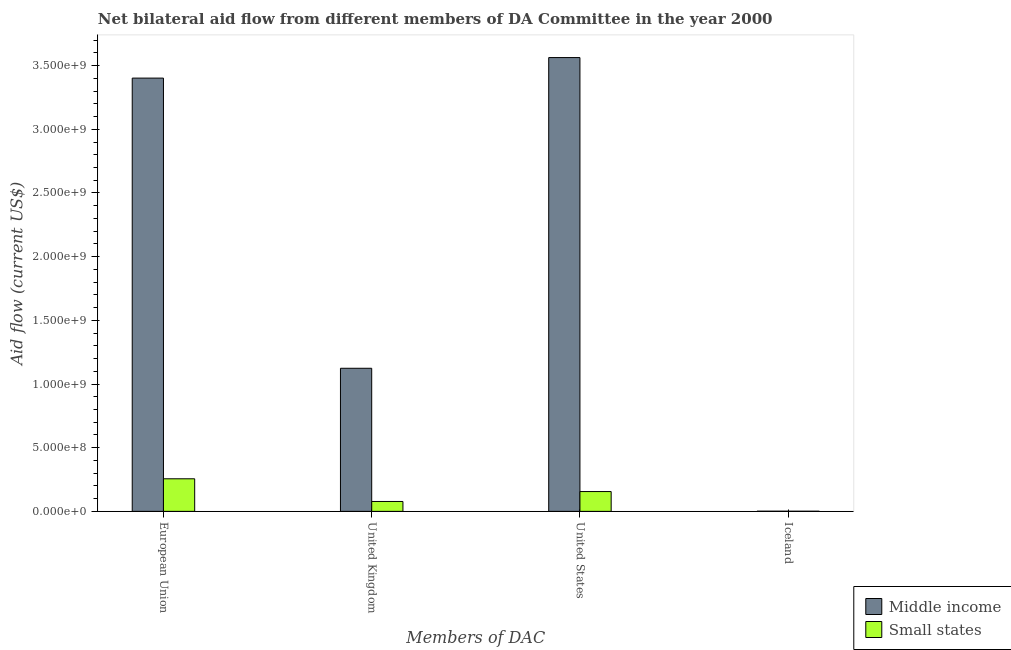Are the number of bars on each tick of the X-axis equal?
Provide a succinct answer. Yes. What is the amount of aid given by uk in Middle income?
Your answer should be very brief. 1.12e+09. Across all countries, what is the maximum amount of aid given by eu?
Offer a very short reply. 3.40e+09. Across all countries, what is the minimum amount of aid given by us?
Your answer should be very brief. 1.56e+08. In which country was the amount of aid given by iceland maximum?
Your answer should be compact. Middle income. In which country was the amount of aid given by eu minimum?
Make the answer very short. Small states. What is the total amount of aid given by us in the graph?
Your answer should be very brief. 3.72e+09. What is the difference between the amount of aid given by eu in Middle income and that in Small states?
Offer a terse response. 3.15e+09. What is the difference between the amount of aid given by uk in Small states and the amount of aid given by eu in Middle income?
Give a very brief answer. -3.32e+09. What is the average amount of aid given by us per country?
Provide a succinct answer. 1.86e+09. What is the difference between the amount of aid given by iceland and amount of aid given by uk in Middle income?
Your response must be concise. -1.12e+09. In how many countries, is the amount of aid given by uk greater than 2800000000 US$?
Offer a terse response. 0. What is the ratio of the amount of aid given by iceland in Small states to that in Middle income?
Your answer should be very brief. 0.83. Is the amount of aid given by uk in Small states less than that in Middle income?
Offer a terse response. Yes. Is the difference between the amount of aid given by uk in Small states and Middle income greater than the difference between the amount of aid given by iceland in Small states and Middle income?
Keep it short and to the point. No. What is the difference between the highest and the second highest amount of aid given by iceland?
Your answer should be very brief. 2.10e+05. What is the difference between the highest and the lowest amount of aid given by us?
Provide a short and direct response. 3.41e+09. What does the 1st bar from the right in United Kingdom represents?
Your answer should be compact. Small states. How many bars are there?
Give a very brief answer. 8. Are the values on the major ticks of Y-axis written in scientific E-notation?
Provide a short and direct response. Yes. Does the graph contain grids?
Give a very brief answer. No. What is the title of the graph?
Give a very brief answer. Net bilateral aid flow from different members of DA Committee in the year 2000. Does "Nigeria" appear as one of the legend labels in the graph?
Keep it short and to the point. No. What is the label or title of the X-axis?
Your answer should be very brief. Members of DAC. What is the label or title of the Y-axis?
Provide a succinct answer. Aid flow (current US$). What is the Aid flow (current US$) of Middle income in European Union?
Provide a succinct answer. 3.40e+09. What is the Aid flow (current US$) in Small states in European Union?
Offer a terse response. 2.56e+08. What is the Aid flow (current US$) of Middle income in United Kingdom?
Offer a very short reply. 1.12e+09. What is the Aid flow (current US$) of Small states in United Kingdom?
Provide a succinct answer. 7.76e+07. What is the Aid flow (current US$) in Middle income in United States?
Provide a short and direct response. 3.56e+09. What is the Aid flow (current US$) of Small states in United States?
Make the answer very short. 1.56e+08. What is the Aid flow (current US$) of Middle income in Iceland?
Provide a succinct answer. 1.26e+06. What is the Aid flow (current US$) in Small states in Iceland?
Offer a very short reply. 1.05e+06. Across all Members of DAC, what is the maximum Aid flow (current US$) of Middle income?
Offer a terse response. 3.56e+09. Across all Members of DAC, what is the maximum Aid flow (current US$) of Small states?
Offer a terse response. 2.56e+08. Across all Members of DAC, what is the minimum Aid flow (current US$) in Middle income?
Ensure brevity in your answer.  1.26e+06. Across all Members of DAC, what is the minimum Aid flow (current US$) of Small states?
Offer a terse response. 1.05e+06. What is the total Aid flow (current US$) of Middle income in the graph?
Offer a terse response. 8.09e+09. What is the total Aid flow (current US$) in Small states in the graph?
Give a very brief answer. 4.90e+08. What is the difference between the Aid flow (current US$) in Middle income in European Union and that in United Kingdom?
Keep it short and to the point. 2.28e+09. What is the difference between the Aid flow (current US$) in Small states in European Union and that in United Kingdom?
Give a very brief answer. 1.78e+08. What is the difference between the Aid flow (current US$) in Middle income in European Union and that in United States?
Provide a succinct answer. -1.61e+08. What is the difference between the Aid flow (current US$) of Small states in European Union and that in United States?
Your answer should be very brief. 1.00e+08. What is the difference between the Aid flow (current US$) of Middle income in European Union and that in Iceland?
Your answer should be compact. 3.40e+09. What is the difference between the Aid flow (current US$) of Small states in European Union and that in Iceland?
Your response must be concise. 2.55e+08. What is the difference between the Aid flow (current US$) of Middle income in United Kingdom and that in United States?
Offer a terse response. -2.44e+09. What is the difference between the Aid flow (current US$) of Small states in United Kingdom and that in United States?
Your answer should be very brief. -7.80e+07. What is the difference between the Aid flow (current US$) in Middle income in United Kingdom and that in Iceland?
Ensure brevity in your answer.  1.12e+09. What is the difference between the Aid flow (current US$) of Small states in United Kingdom and that in Iceland?
Provide a short and direct response. 7.66e+07. What is the difference between the Aid flow (current US$) of Middle income in United States and that in Iceland?
Offer a terse response. 3.56e+09. What is the difference between the Aid flow (current US$) of Small states in United States and that in Iceland?
Provide a short and direct response. 1.55e+08. What is the difference between the Aid flow (current US$) of Middle income in European Union and the Aid flow (current US$) of Small states in United Kingdom?
Your response must be concise. 3.32e+09. What is the difference between the Aid flow (current US$) of Middle income in European Union and the Aid flow (current US$) of Small states in United States?
Offer a terse response. 3.25e+09. What is the difference between the Aid flow (current US$) of Middle income in European Union and the Aid flow (current US$) of Small states in Iceland?
Offer a very short reply. 3.40e+09. What is the difference between the Aid flow (current US$) in Middle income in United Kingdom and the Aid flow (current US$) in Small states in United States?
Ensure brevity in your answer.  9.68e+08. What is the difference between the Aid flow (current US$) of Middle income in United Kingdom and the Aid flow (current US$) of Small states in Iceland?
Provide a short and direct response. 1.12e+09. What is the difference between the Aid flow (current US$) of Middle income in United States and the Aid flow (current US$) of Small states in Iceland?
Provide a succinct answer. 3.56e+09. What is the average Aid flow (current US$) in Middle income per Members of DAC?
Provide a short and direct response. 2.02e+09. What is the average Aid flow (current US$) of Small states per Members of DAC?
Keep it short and to the point. 1.23e+08. What is the difference between the Aid flow (current US$) of Middle income and Aid flow (current US$) of Small states in European Union?
Provide a succinct answer. 3.15e+09. What is the difference between the Aid flow (current US$) in Middle income and Aid flow (current US$) in Small states in United Kingdom?
Ensure brevity in your answer.  1.05e+09. What is the difference between the Aid flow (current US$) of Middle income and Aid flow (current US$) of Small states in United States?
Ensure brevity in your answer.  3.41e+09. What is the ratio of the Aid flow (current US$) of Middle income in European Union to that in United Kingdom?
Offer a very short reply. 3.03. What is the ratio of the Aid flow (current US$) of Small states in European Union to that in United Kingdom?
Provide a short and direct response. 3.29. What is the ratio of the Aid flow (current US$) of Middle income in European Union to that in United States?
Provide a succinct answer. 0.95. What is the ratio of the Aid flow (current US$) in Small states in European Union to that in United States?
Your response must be concise. 1.64. What is the ratio of the Aid flow (current US$) of Middle income in European Union to that in Iceland?
Your answer should be compact. 2699.98. What is the ratio of the Aid flow (current US$) of Small states in European Union to that in Iceland?
Provide a succinct answer. 243.56. What is the ratio of the Aid flow (current US$) of Middle income in United Kingdom to that in United States?
Offer a very short reply. 0.32. What is the ratio of the Aid flow (current US$) in Small states in United Kingdom to that in United States?
Your answer should be very brief. 0.5. What is the ratio of the Aid flow (current US$) in Middle income in United Kingdom to that in Iceland?
Provide a succinct answer. 891.75. What is the ratio of the Aid flow (current US$) in Small states in United Kingdom to that in Iceland?
Your answer should be very brief. 73.95. What is the ratio of the Aid flow (current US$) in Middle income in United States to that in Iceland?
Your response must be concise. 2828.01. What is the ratio of the Aid flow (current US$) of Small states in United States to that in Iceland?
Keep it short and to the point. 148.19. What is the difference between the highest and the second highest Aid flow (current US$) in Middle income?
Keep it short and to the point. 1.61e+08. What is the difference between the highest and the second highest Aid flow (current US$) of Small states?
Provide a succinct answer. 1.00e+08. What is the difference between the highest and the lowest Aid flow (current US$) in Middle income?
Make the answer very short. 3.56e+09. What is the difference between the highest and the lowest Aid flow (current US$) in Small states?
Provide a succinct answer. 2.55e+08. 